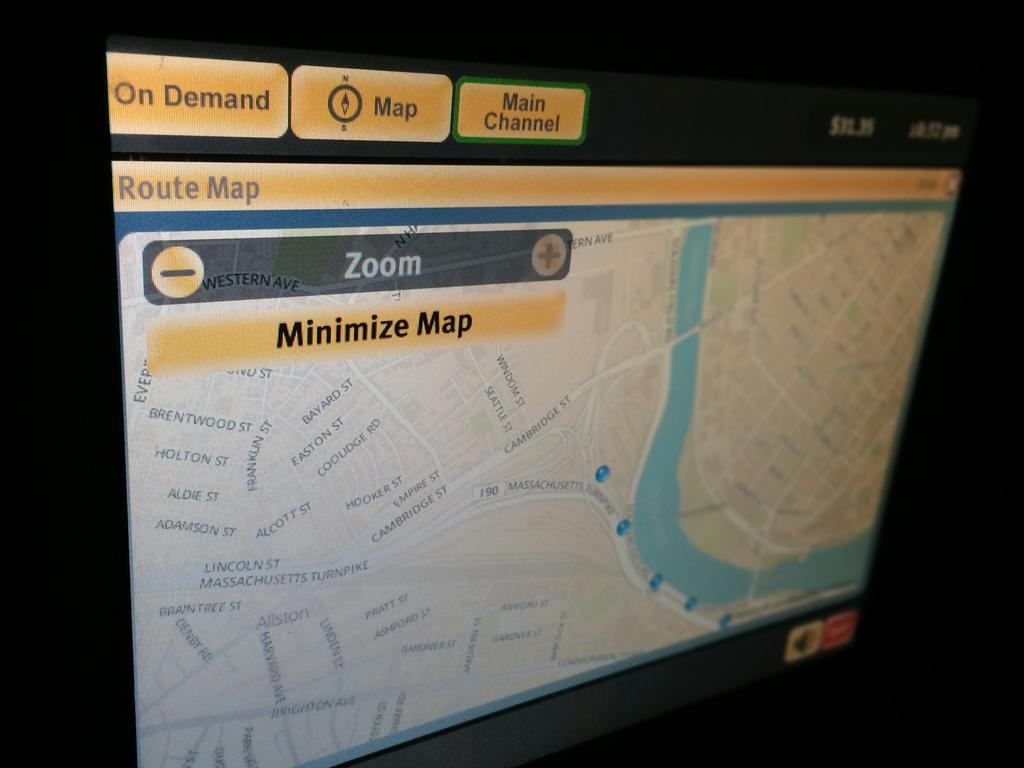<image>
Write a terse but informative summary of the picture. Computer monitor with a minimize map icon in the top 